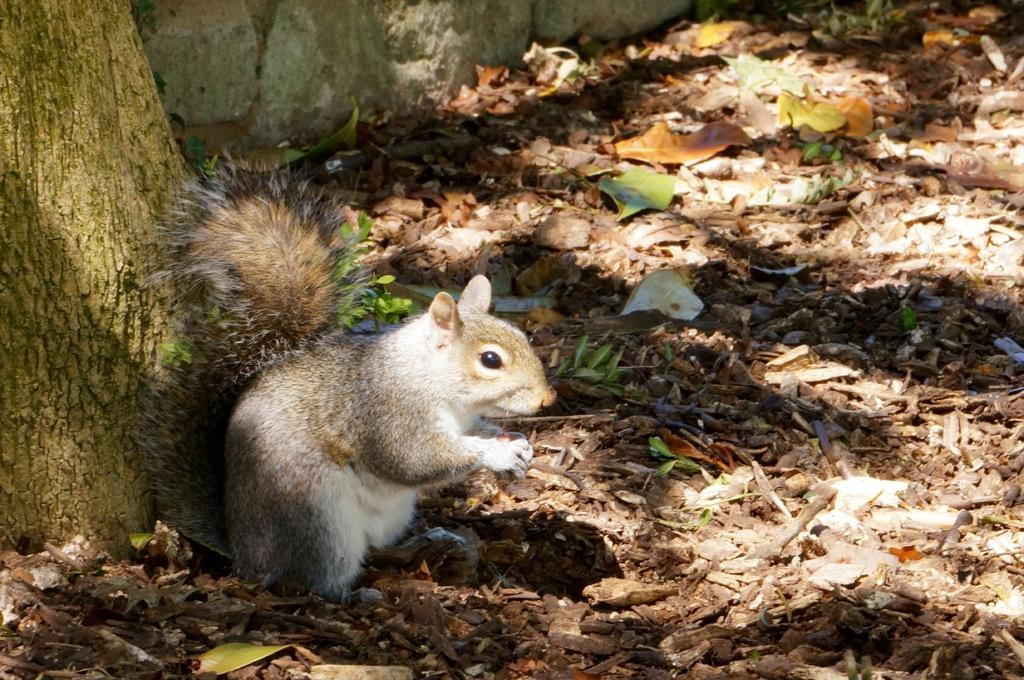What type of animal is in the image? There is a squirrel in the image. Where is the squirrel located in relation to the stem? The squirrel is in front of a stem in the image. What can be seen on the ground in the image? There are leaves on the ground in the image. How many glasses of water are present in the image? There are no glasses of water visible in the image. What type of plant is growing on the squirrel's head? There is no plant growing on the squirrel's head in the image. 